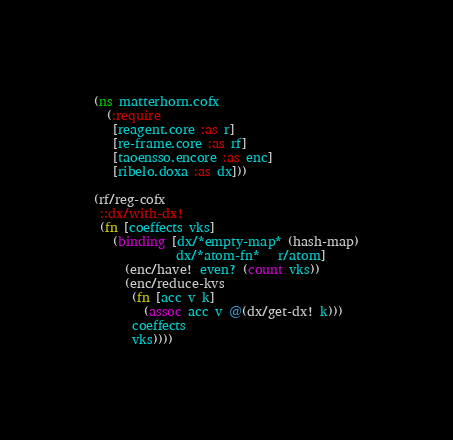<code> <loc_0><loc_0><loc_500><loc_500><_Clojure_>(ns matterhorn.cofx
  (:require
   [reagent.core :as r]
   [re-frame.core :as rf]
   [taoensso.encore :as enc]
   [ribelo.doxa :as dx]))

(rf/reg-cofx
 ::dx/with-dx!
 (fn [coeffects vks]
   (binding [dx/*empty-map* (hash-map)
             dx/*atom-fn*   r/atom]
     (enc/have! even? (count vks))
     (enc/reduce-kvs
      (fn [acc v k]
        (assoc acc v @(dx/get-dx! k)))
      coeffects
      vks))))
</code> 